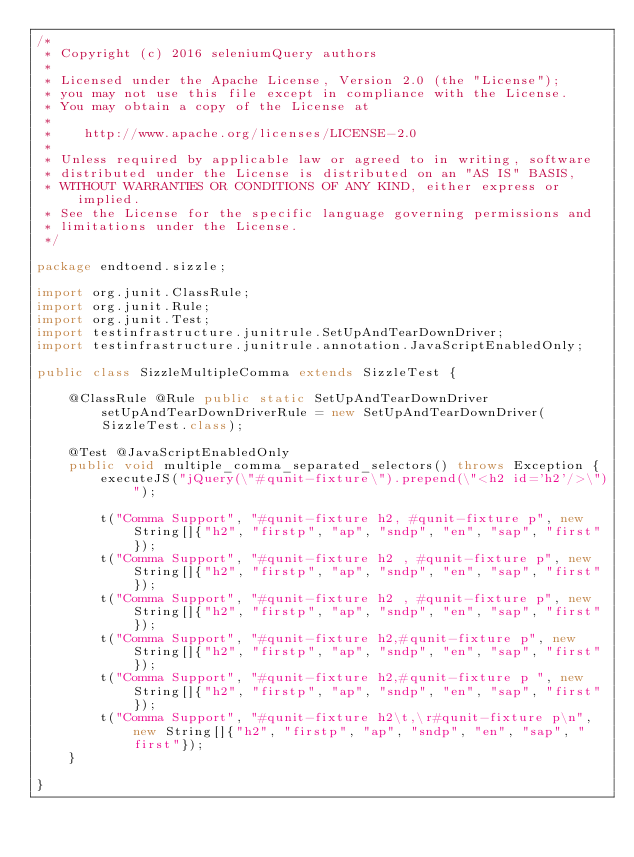Convert code to text. <code><loc_0><loc_0><loc_500><loc_500><_Java_>/*
 * Copyright (c) 2016 seleniumQuery authors
 *
 * Licensed under the Apache License, Version 2.0 (the "License");
 * you may not use this file except in compliance with the License.
 * You may obtain a copy of the License at
 *
 *    http://www.apache.org/licenses/LICENSE-2.0
 *
 * Unless required by applicable law or agreed to in writing, software
 * distributed under the License is distributed on an "AS IS" BASIS,
 * WITHOUT WARRANTIES OR CONDITIONS OF ANY KIND, either express or implied.
 * See the License for the specific language governing permissions and
 * limitations under the License.
 */

package endtoend.sizzle;

import org.junit.ClassRule;
import org.junit.Rule;
import org.junit.Test;
import testinfrastructure.junitrule.SetUpAndTearDownDriver;
import testinfrastructure.junitrule.annotation.JavaScriptEnabledOnly;

public class SizzleMultipleComma extends SizzleTest {

    @ClassRule @Rule public static SetUpAndTearDownDriver setUpAndTearDownDriverRule = new SetUpAndTearDownDriver(SizzleTest.class);

    @Test @JavaScriptEnabledOnly
    public void multiple_comma_separated_selectors() throws Exception {
        executeJS("jQuery(\"#qunit-fixture\").prepend(\"<h2 id='h2'/>\")");

        t("Comma Support", "#qunit-fixture h2, #qunit-fixture p", new String[]{"h2", "firstp", "ap", "sndp", "en", "sap", "first"});
        t("Comma Support", "#qunit-fixture h2 , #qunit-fixture p", new String[]{"h2", "firstp", "ap", "sndp", "en", "sap", "first"});
        t("Comma Support", "#qunit-fixture h2 , #qunit-fixture p", new String[]{"h2", "firstp", "ap", "sndp", "en", "sap", "first"});
        t("Comma Support", "#qunit-fixture h2,#qunit-fixture p", new String[]{"h2", "firstp", "ap", "sndp", "en", "sap", "first"});
        t("Comma Support", "#qunit-fixture h2,#qunit-fixture p ", new String[]{"h2", "firstp", "ap", "sndp", "en", "sap", "first"});
        t("Comma Support", "#qunit-fixture h2\t,\r#qunit-fixture p\n", new String[]{"h2", "firstp", "ap", "sndp", "en", "sap", "first"});
    }

}
</code> 